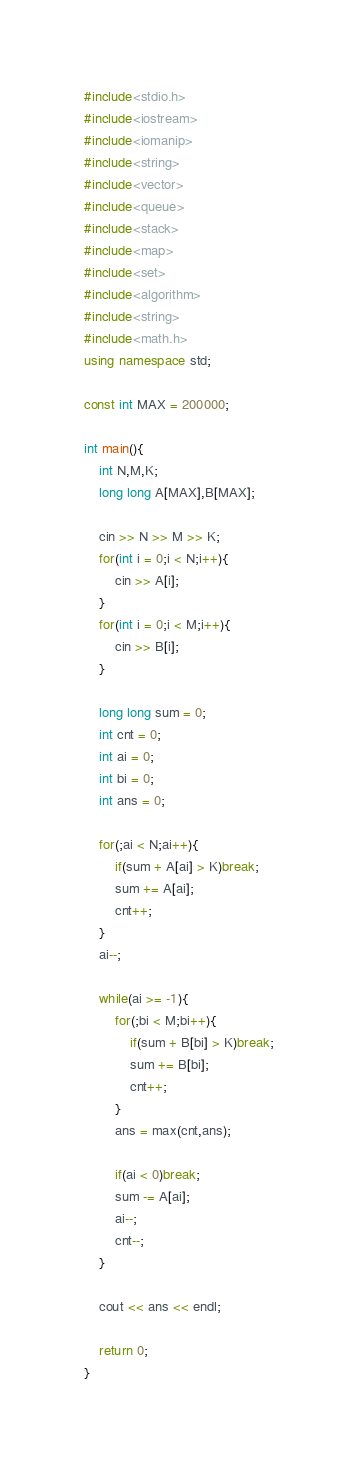<code> <loc_0><loc_0><loc_500><loc_500><_C++_>#include<stdio.h>
#include<iostream>
#include<iomanip>
#include<string>
#include<vector>
#include<queue>
#include<stack>
#include<map>
#include<set>
#include<algorithm>
#include<string>
#include<math.h>
using namespace std;
 
const int MAX = 200000;
 
int main(){
    int N,M,K;
    long long A[MAX],B[MAX];
 
    cin >> N >> M >> K;
    for(int i = 0;i < N;i++){
        cin >> A[i];
    }
    for(int i = 0;i < M;i++){
        cin >> B[i];
    }
 
    long long sum = 0;
    int cnt = 0;
    int ai = 0;
    int bi = 0;
    int ans = 0;
 
    for(;ai < N;ai++){
        if(sum + A[ai] > K)break;
        sum += A[ai];
        cnt++;
    }
    ai--;
 
    while(ai >= -1){
        for(;bi < M;bi++){
            if(sum + B[bi] > K)break;
            sum += B[bi];
            cnt++;
        }
        ans = max(cnt,ans);
 
        if(ai < 0)break;
        sum -= A[ai];
        ai--;
        cnt--;
    }
 
    cout << ans << endl;
 
    return 0;
}</code> 